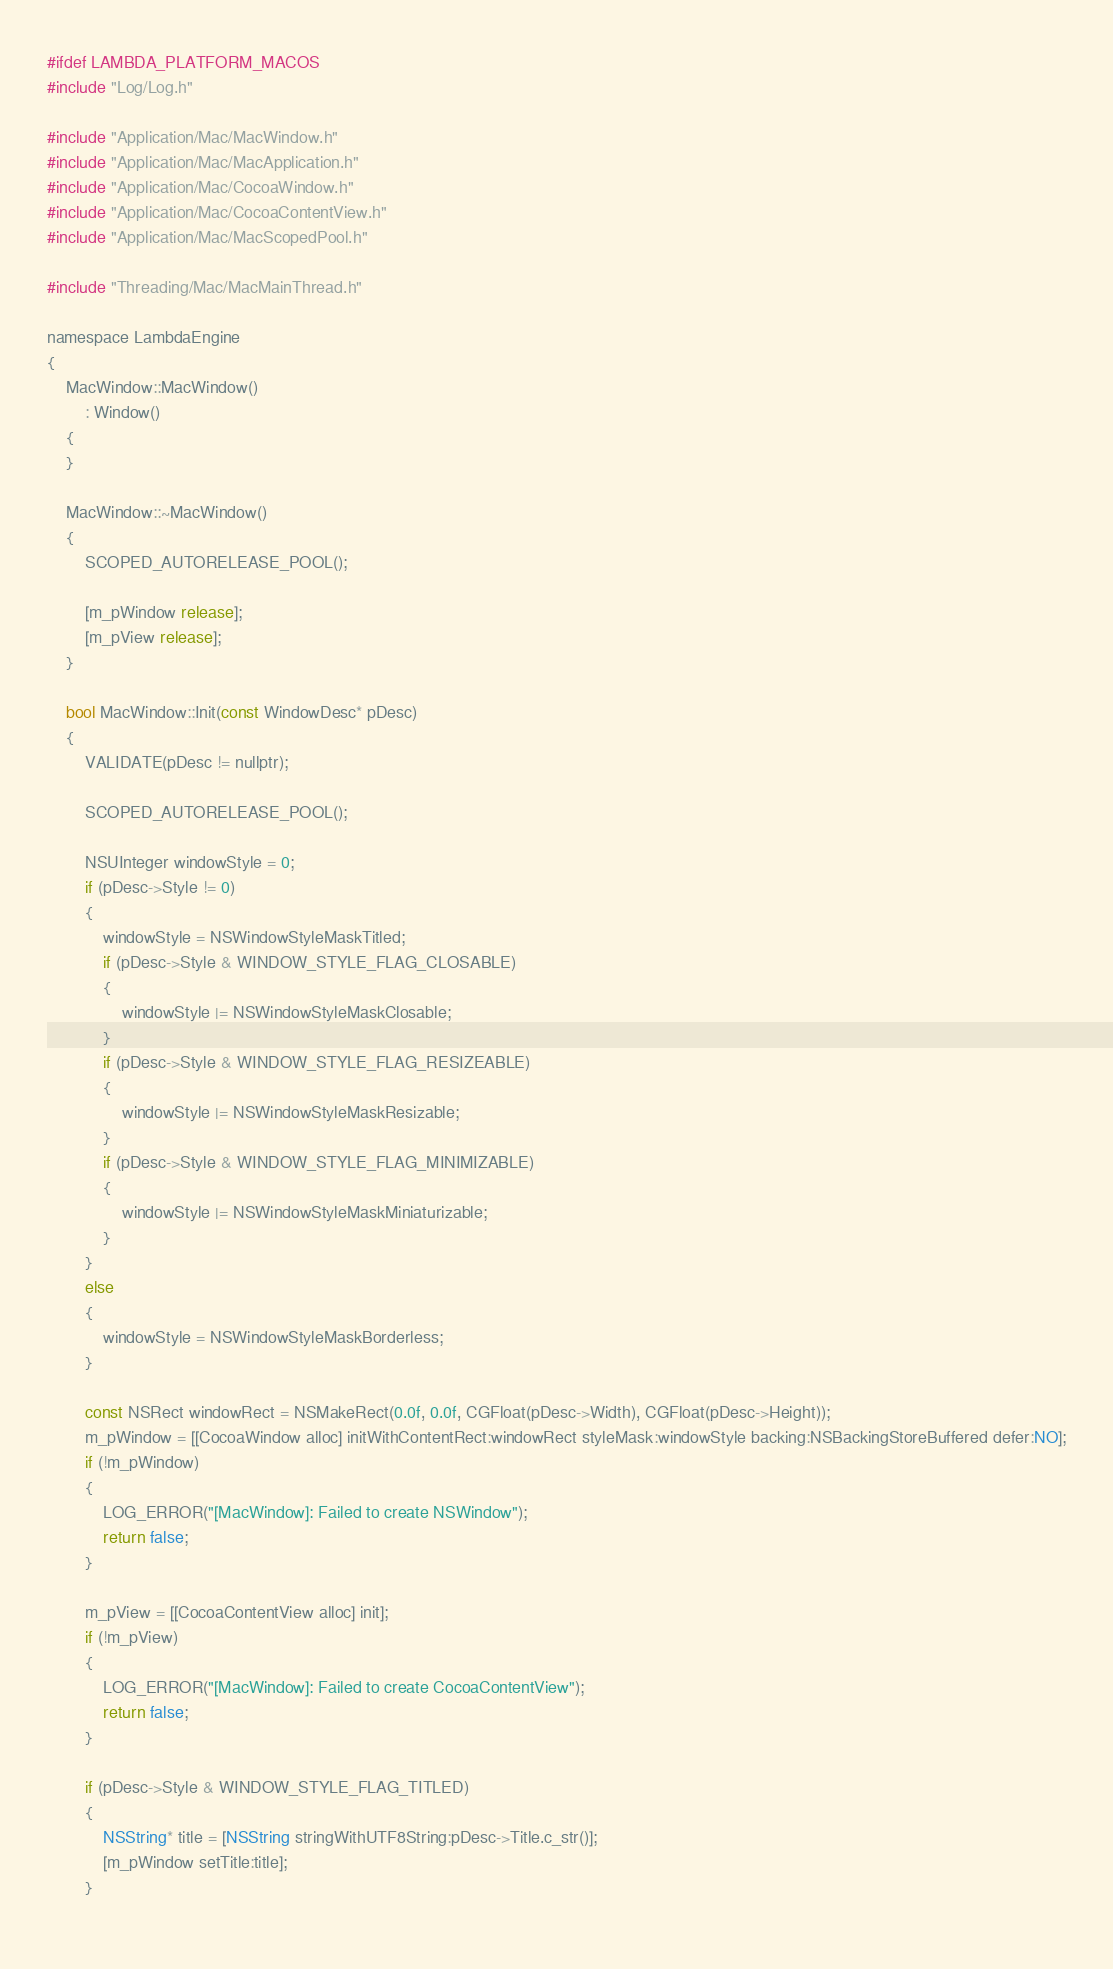Convert code to text. <code><loc_0><loc_0><loc_500><loc_500><_ObjectiveC_>#ifdef LAMBDA_PLATFORM_MACOS
#include "Log/Log.h"

#include "Application/Mac/MacWindow.h"
#include "Application/Mac/MacApplication.h"
#include "Application/Mac/CocoaWindow.h"
#include "Application/Mac/CocoaContentView.h"
#include "Application/Mac/MacScopedPool.h"

#include "Threading/Mac/MacMainThread.h"

namespace LambdaEngine
{
    MacWindow::MacWindow()
        : Window()
    {
    }

    MacWindow::~MacWindow()
    {
        SCOPED_AUTORELEASE_POOL();
        
        [m_pWindow release];
        [m_pView release];
    }

    bool MacWindow::Init(const WindowDesc* pDesc)
    {
		VALIDATE(pDesc != nullptr);
		
        SCOPED_AUTORELEASE_POOL();
        
		NSUInteger windowStyle = 0;
		if (pDesc->Style != 0)
		{
			windowStyle = NSWindowStyleMaskTitled;
			if (pDesc->Style & WINDOW_STYLE_FLAG_CLOSABLE)
			{
				windowStyle |= NSWindowStyleMaskClosable;
			}
			if (pDesc->Style & WINDOW_STYLE_FLAG_RESIZEABLE)
			{
				windowStyle |= NSWindowStyleMaskResizable;
			}
			if (pDesc->Style & WINDOW_STYLE_FLAG_MINIMIZABLE)
			{
				windowStyle |= NSWindowStyleMaskMiniaturizable;
			}
		}
		else
		{
			windowStyle = NSWindowStyleMaskBorderless;
		}
		
		const NSRect windowRect = NSMakeRect(0.0f, 0.0f, CGFloat(pDesc->Width), CGFloat(pDesc->Height));
        m_pWindow = [[CocoaWindow alloc] initWithContentRect:windowRect styleMask:windowStyle backing:NSBackingStoreBuffered defer:NO];
        if (!m_pWindow)
        {
            LOG_ERROR("[MacWindow]: Failed to create NSWindow");
            return false;
        }
        
        m_pView = [[CocoaContentView alloc] init];
        if (!m_pView)
        {
            LOG_ERROR("[MacWindow]: Failed to create CocoaContentView");
            return false;
        }
        
		if (pDesc->Style & WINDOW_STYLE_FLAG_TITLED)
		{
			NSString* title = [NSString stringWithUTF8String:pDesc->Title.c_str()];
			[m_pWindow setTitle:title];
		}
		</code> 